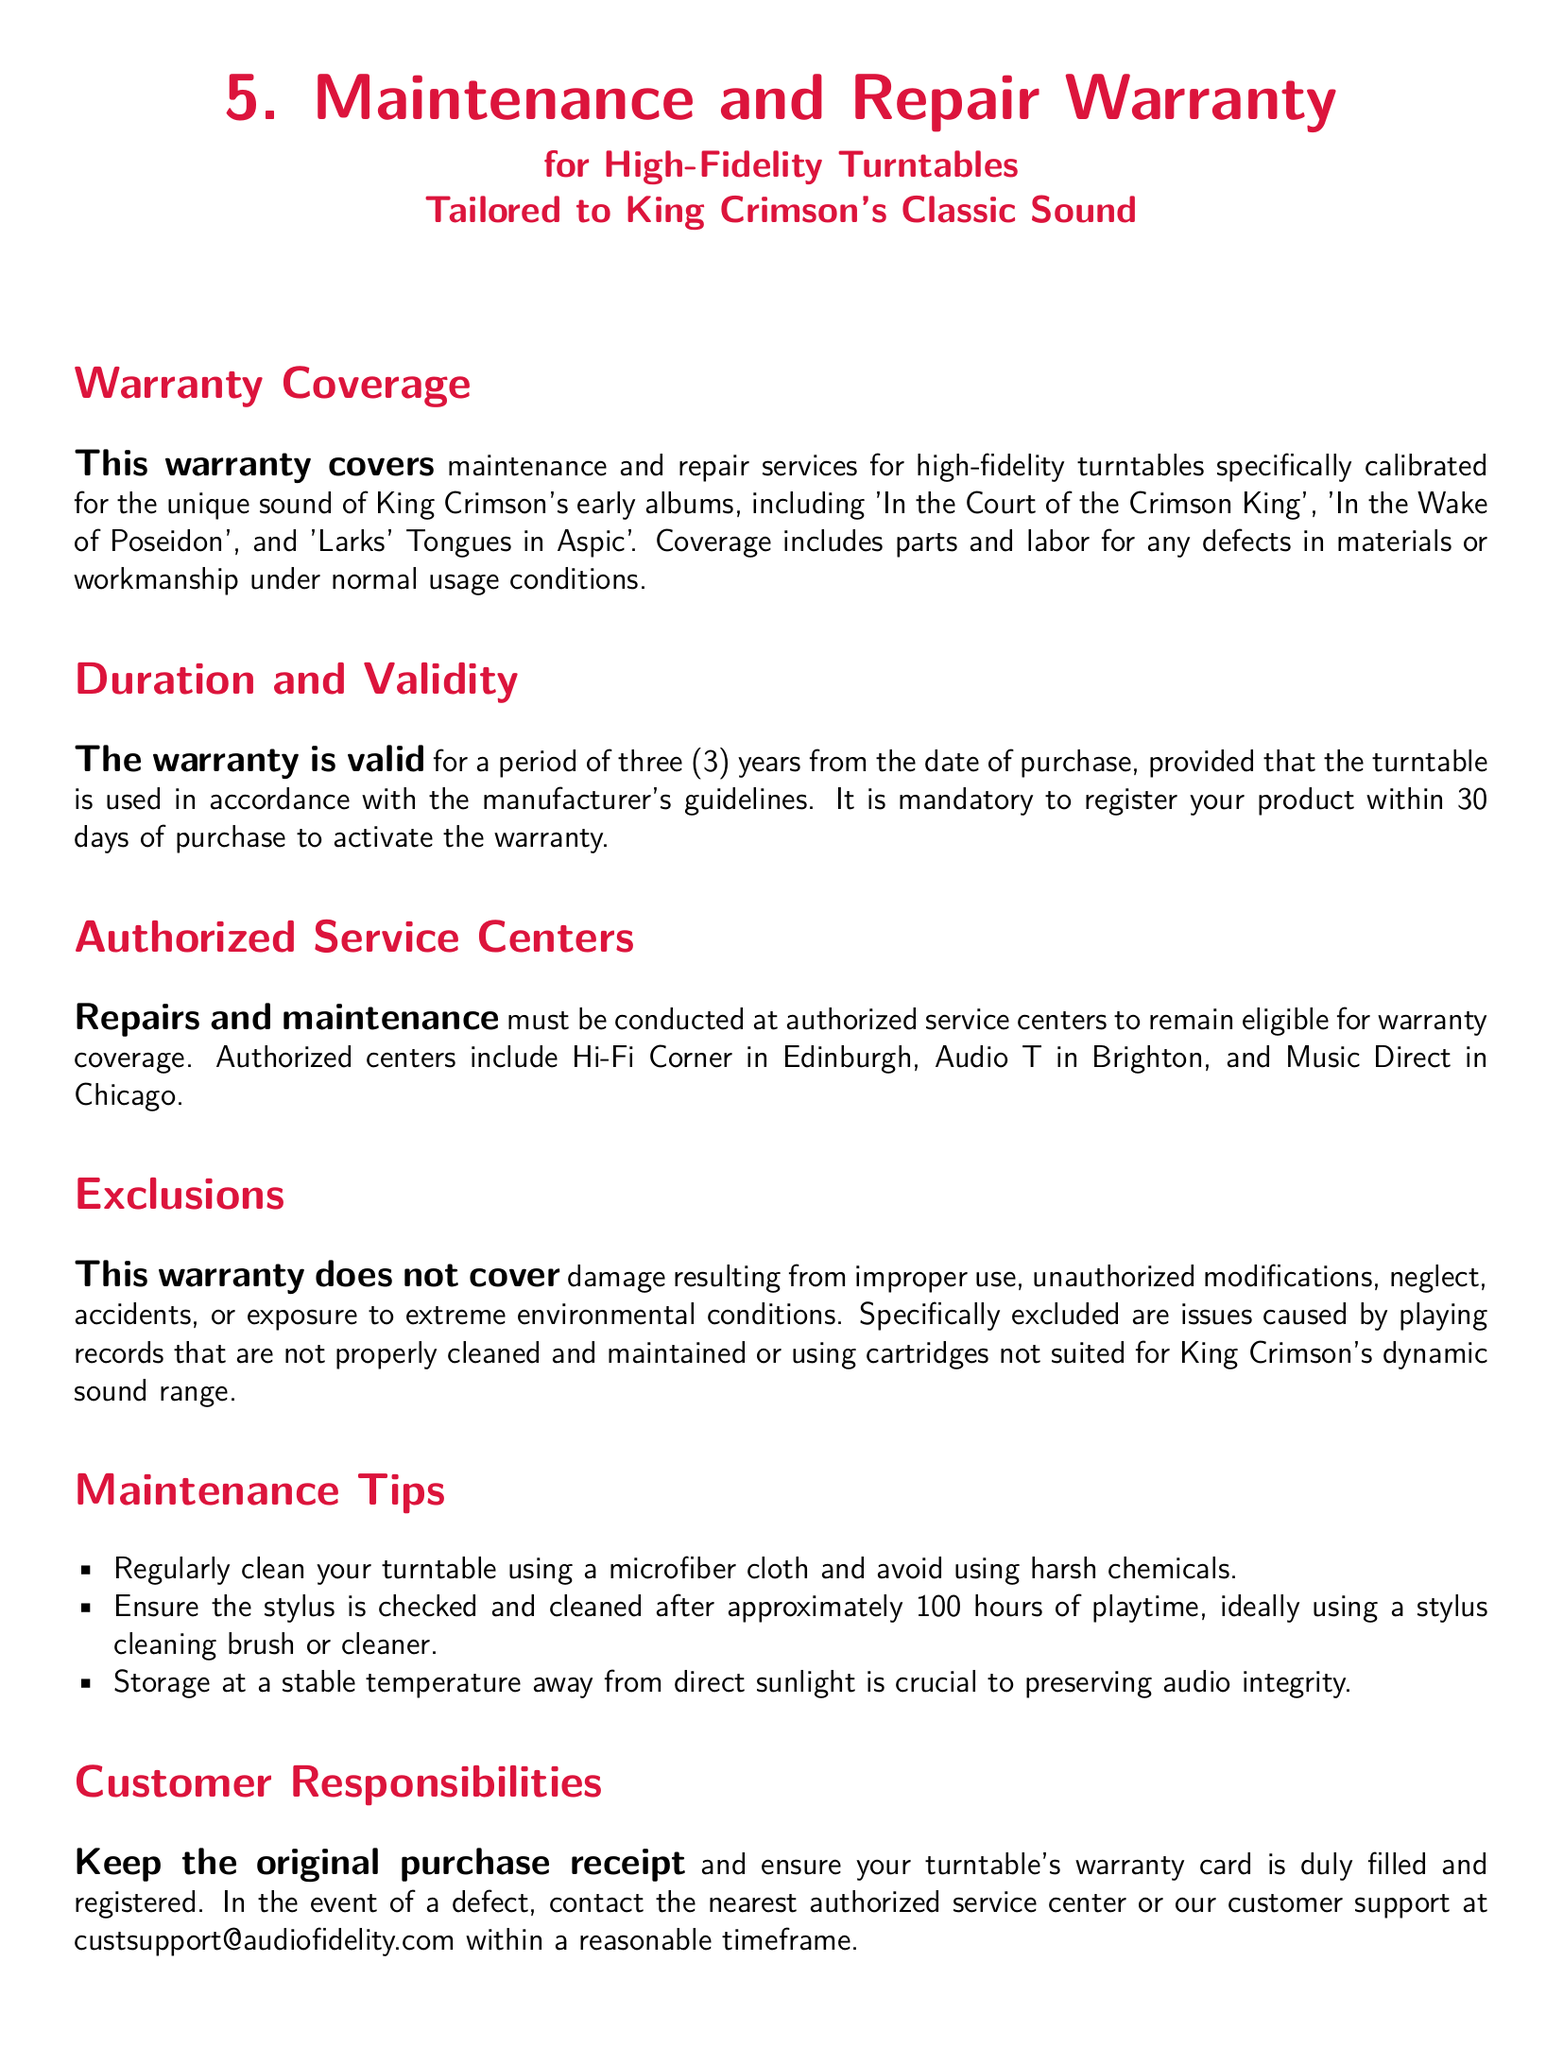What is the duration of the warranty? The warranty is valid for a period of three years from the date of purchase.
Answer: three years Where must repairs be conducted? Repairs and maintenance must be conducted at authorized service centers.
Answer: authorized service centers What is the email for customer support? The contact email for customer support is listed in the document for inquiries regarding defects.
Answer: custsupport@audiofidelity.com What type of products does the warranty cover? The warranty covers maintenance and repair services for high-fidelity turntables.
Answer: high-fidelity turntables What must you do within 30 days of purchase? To activate the warranty, it is mandatory to register your product within 30 days of purchase.
Answer: register your product Which album is mentioned as part of the warranty coverage? The document specifies that the warranty covers turntables calibrated for the unique sound of early King Crimson albums.
Answer: 'In the Court of the Crimson King' What should be kept as customer responsibility? The customer is responsible for keeping the original purchase receipt.
Answer: original purchase receipt What excludes coverage under the warranty? Damage resulting from improper use is explicitly mentioned as an exclusion.
Answer: improper use 